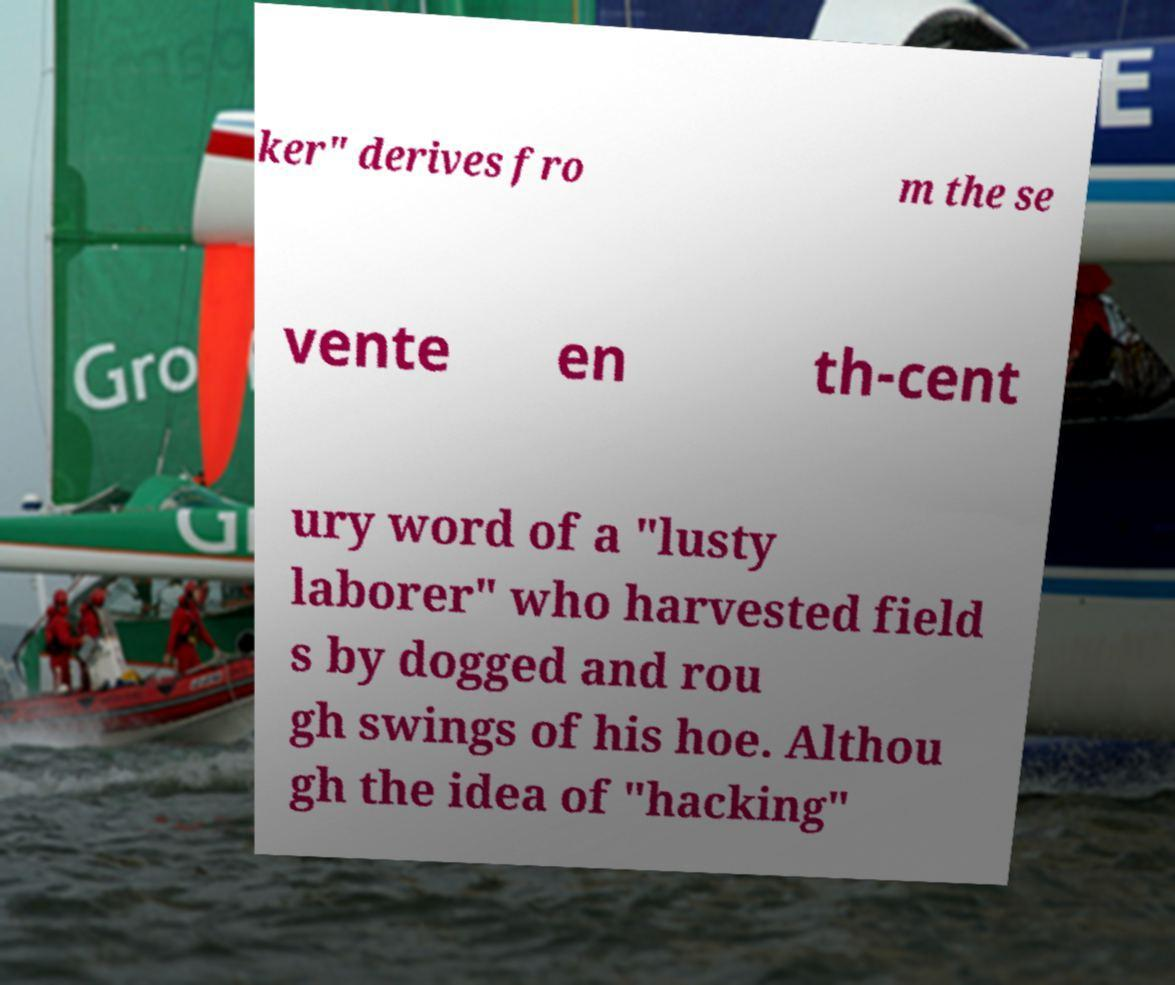Could you extract and type out the text from this image? ker" derives fro m the se vente en th-cent ury word of a "lusty laborer" who harvested field s by dogged and rou gh swings of his hoe. Althou gh the idea of "hacking" 